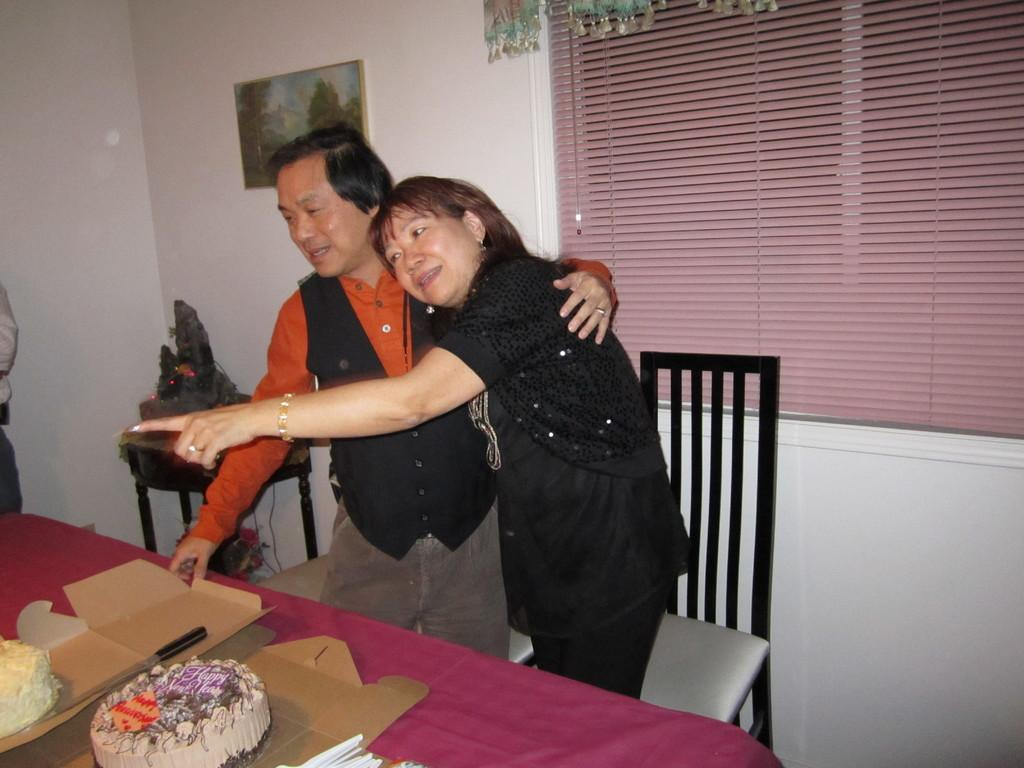What type of structure can be seen in the image? There is a wall in the image. What is hanging on the wall? There is a photo frame in the image. What can be seen in the background of the image? There is a window in the image. What piece of furniture is present in the image? There is a table in the image. What is on top of the table? There are cakes and knives on the table. How many people are in the image? There are two people standing in the image. How many balloons are floating in the yard in the image? There are no balloons or yards present in the image. What type of growth can be observed on the cakes in the image? There is no visible growth on the cakes in the image. 